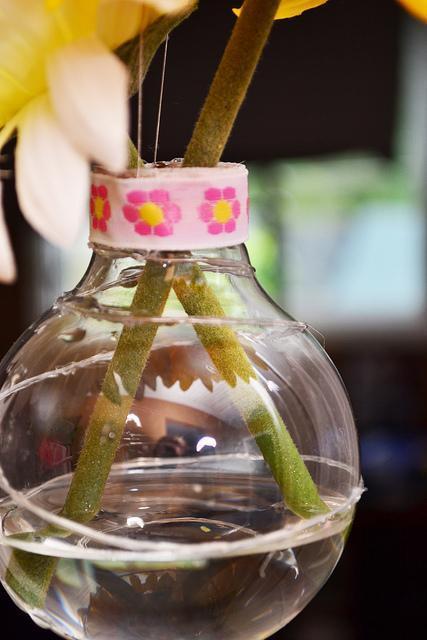How many people will be sharing the pizza?
Give a very brief answer. 0. 